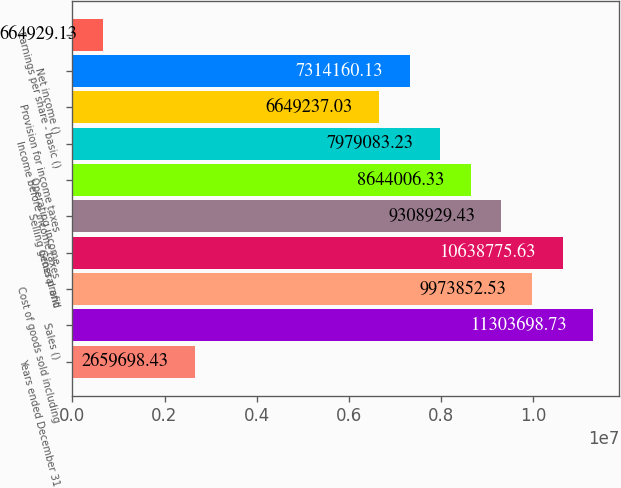Convert chart. <chart><loc_0><loc_0><loc_500><loc_500><bar_chart><fcel>Years ended December 31<fcel>Sales ()<fcel>Cost of goods sold including<fcel>Gross profit<fcel>Selling general and<fcel>Operating income<fcel>Income before income taxes<fcel>Provision for income taxes<fcel>Net income ()<fcel>Earnings per share - basic ()<nl><fcel>2.6597e+06<fcel>1.13037e+07<fcel>9.97385e+06<fcel>1.06388e+07<fcel>9.30893e+06<fcel>8.64401e+06<fcel>7.97908e+06<fcel>6.64924e+06<fcel>7.31416e+06<fcel>664929<nl></chart> 